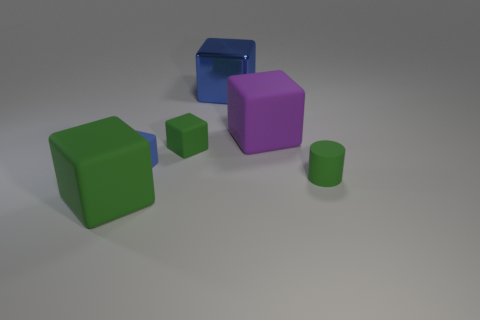Subtract all purple blocks. How many blocks are left? 4 Subtract all purple blocks. How many blocks are left? 4 Add 3 tiny gray cylinders. How many objects exist? 9 Subtract all gray blocks. Subtract all blue balls. How many blocks are left? 5 Subtract all blocks. How many objects are left? 1 Subtract all cylinders. Subtract all small blue cubes. How many objects are left? 4 Add 6 purple blocks. How many purple blocks are left? 7 Add 6 tiny green rubber blocks. How many tiny green rubber blocks exist? 7 Subtract 1 green cubes. How many objects are left? 5 